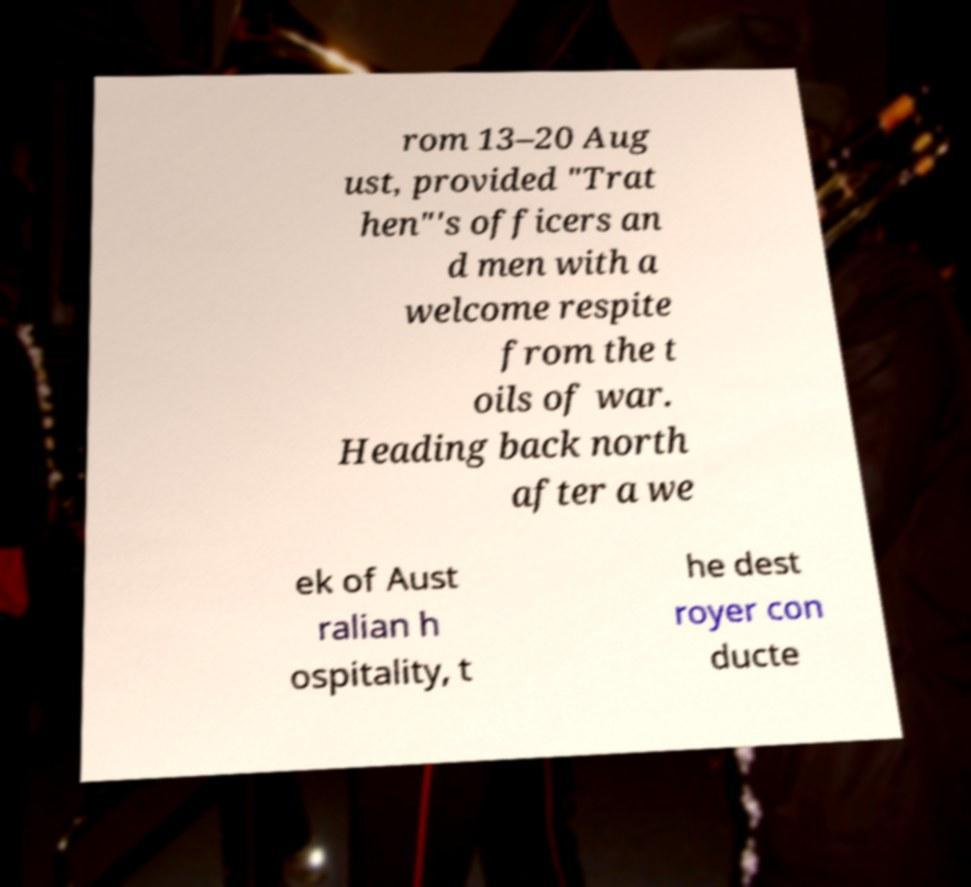Please read and relay the text visible in this image. What does it say? rom 13–20 Aug ust, provided "Trat hen"'s officers an d men with a welcome respite from the t oils of war. Heading back north after a we ek of Aust ralian h ospitality, t he dest royer con ducte 